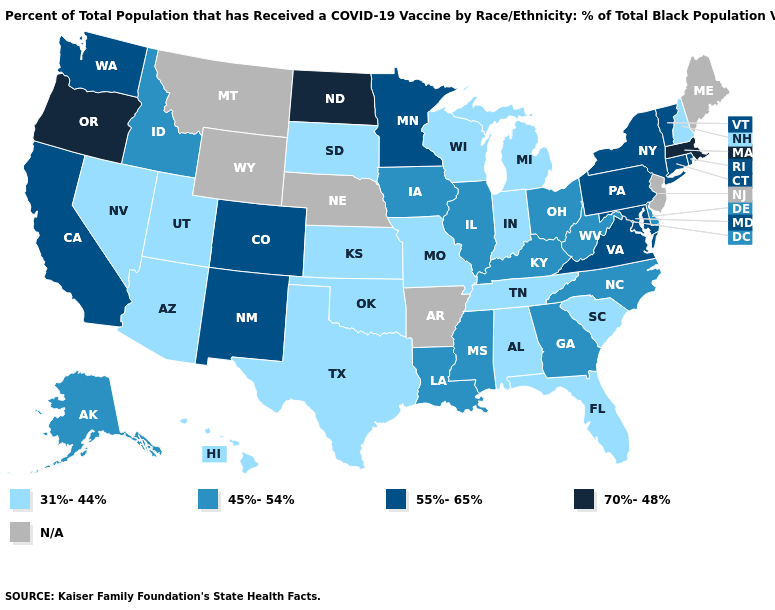Does Idaho have the lowest value in the West?
Concise answer only. No. Is the legend a continuous bar?
Write a very short answer. No. Name the states that have a value in the range 31%-44%?
Keep it brief. Alabama, Arizona, Florida, Hawaii, Indiana, Kansas, Michigan, Missouri, Nevada, New Hampshire, Oklahoma, South Carolina, South Dakota, Tennessee, Texas, Utah, Wisconsin. Name the states that have a value in the range 55%-65%?
Keep it brief. California, Colorado, Connecticut, Maryland, Minnesota, New Mexico, New York, Pennsylvania, Rhode Island, Vermont, Virginia, Washington. Does the map have missing data?
Quick response, please. Yes. What is the highest value in the USA?
Write a very short answer. 70%-48%. Name the states that have a value in the range N/A?
Answer briefly. Arkansas, Maine, Montana, Nebraska, New Jersey, Wyoming. What is the value of Hawaii?
Keep it brief. 31%-44%. Name the states that have a value in the range 70%-48%?
Quick response, please. Massachusetts, North Dakota, Oregon. What is the value of Mississippi?
Answer briefly. 45%-54%. Which states have the lowest value in the Northeast?
Short answer required. New Hampshire. What is the lowest value in the USA?
Write a very short answer. 31%-44%. Name the states that have a value in the range 45%-54%?
Answer briefly. Alaska, Delaware, Georgia, Idaho, Illinois, Iowa, Kentucky, Louisiana, Mississippi, North Carolina, Ohio, West Virginia. 